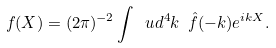Convert formula to latex. <formula><loc_0><loc_0><loc_500><loc_500>f ( X ) = ( 2 \pi ) ^ { - 2 } \int \ u d ^ { 4 } k \ \hat { f } ( - k ) e ^ { i k X } .</formula> 